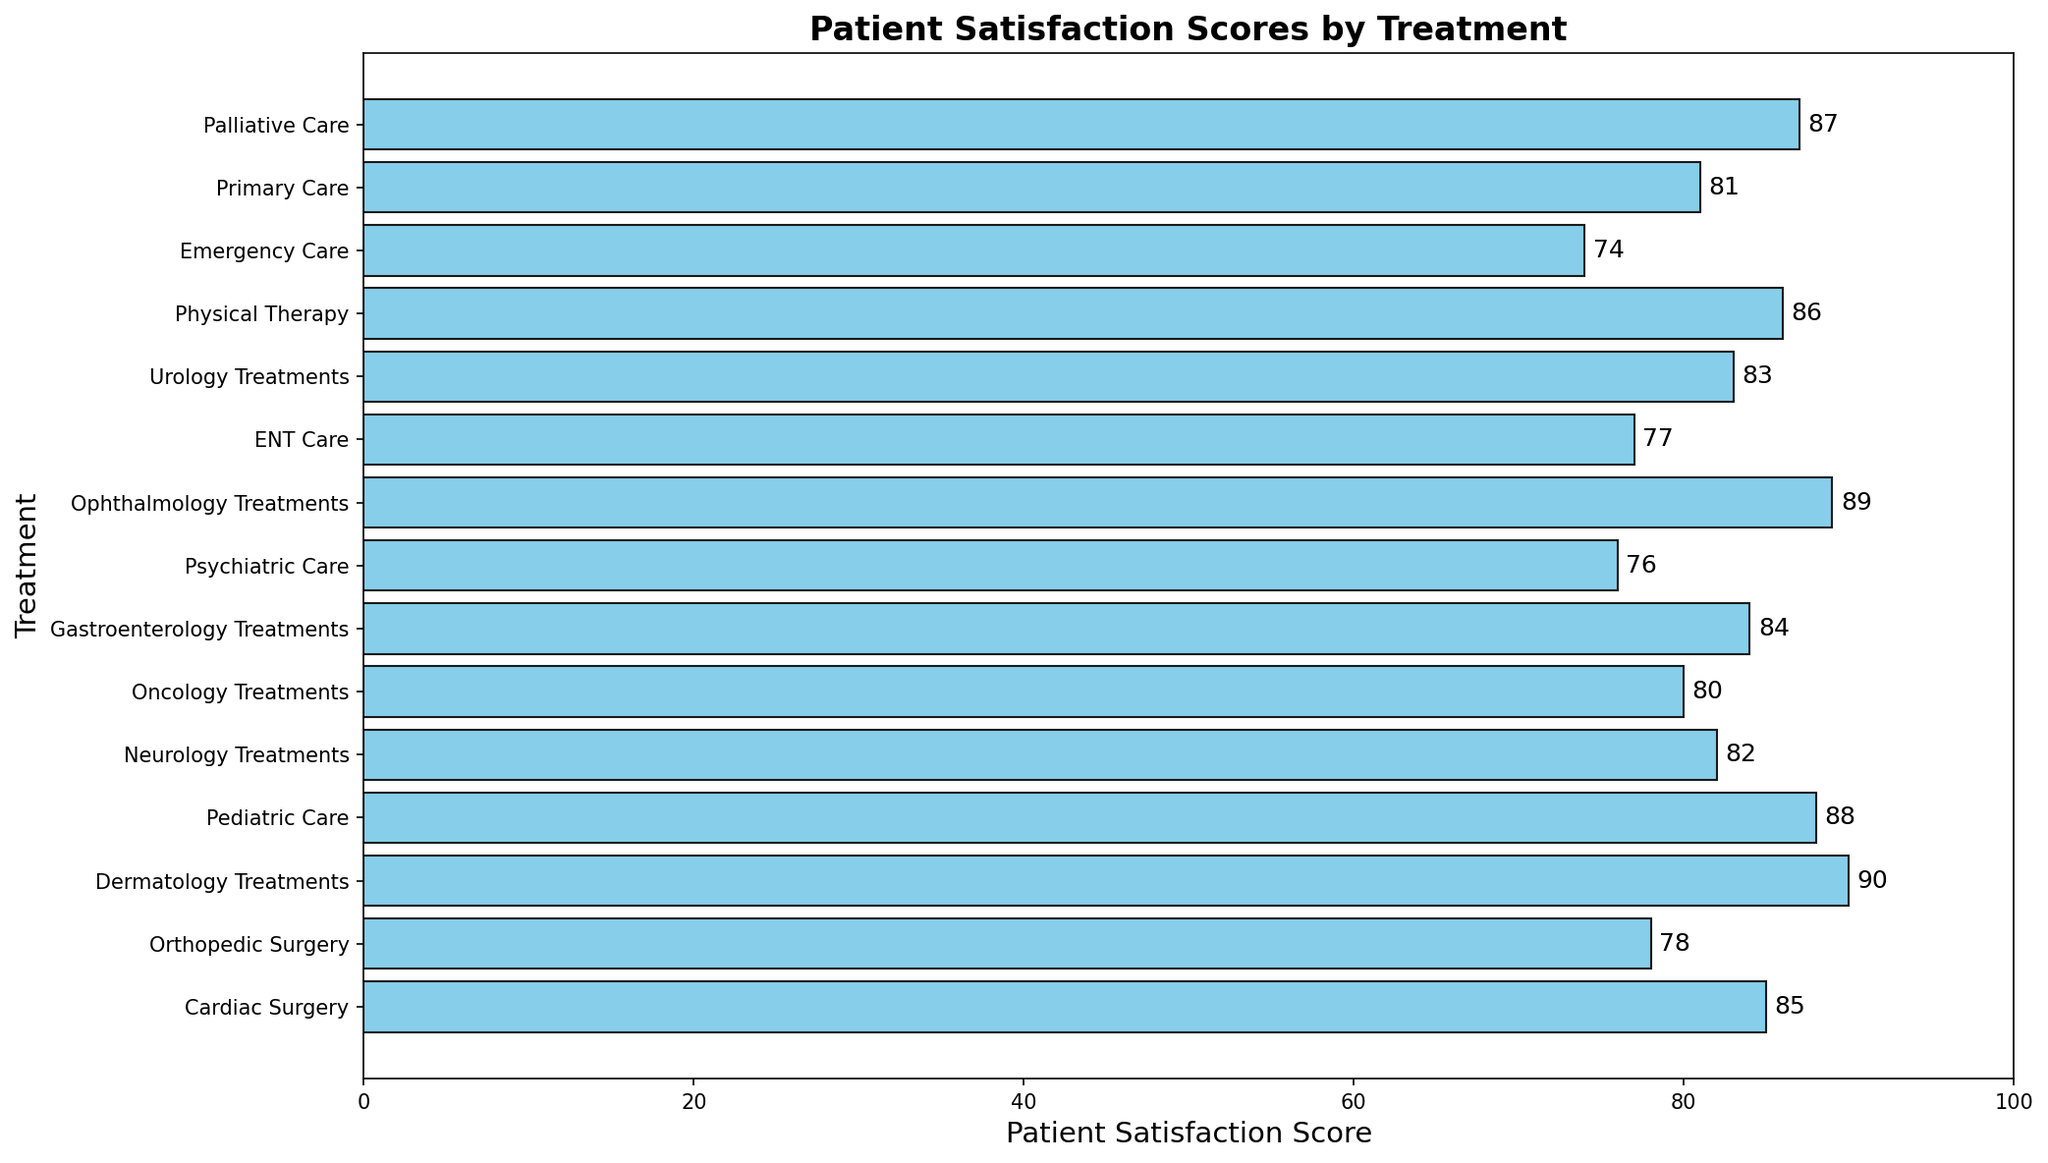What's the highest patient satisfaction score among all treatments? Look at the bar representing the highest score among all the treatments. Dermatology Treatments has the highest bar with a score of 90.
Answer: 90 Which treatment has the lowest patient satisfaction score? Identify the bar with the shortest length. Emergency Care has the shortest bar with a score of 74.
Answer: Emergency Care What is the difference in patient satisfaction scores between Dermatology Treatments and Psychiatric Care? Dermatology Treatments has a score of 90 and Psychiatric Care has a score of 76. The difference is 90 - 76 = 14.
Answer: 14 How many treatments have patient satisfaction scores higher than 80? Count the number of bars with scores greater than 80. There are 9 treatments with scores higher than 80.
Answer: 9 What is the average patient satisfaction score for Dermatology Treatments, Pediatric Care, and Palliative Care? Sum the scores of Dermatology Treatments (90), Pediatric Care (88), and Palliative Care (87) and divide by 3. (90 + 88 + 87) / 3 = 265 / 3 ≈ 88.33.
Answer: 88.33 Which treatment has closer patient satisfaction score to Neurology Treatments: Primary Care or Orthopedic Surgery? Neurology Treatments has a score of 82. Primary Care has a score of 81, and Orthopedic Surgery has a score of 78. The difference is 82 - 81 = 1 for Primary Care and 82 - 78 = 4 for Orthopedic Surgery. Primary Care has a closer score.
Answer: Primary Care Are there more treatments with satisfaction scores above or below 85? Count the treatments with scores above 85 and those below 85. There are 6 treatments above 85 and 9 treatments below 85. There are more treatments below 85.
Answer: Below 85 Which treatments have patient satisfaction scores between 80 and 85? Identify the bars with scores between 80 and 85. These treatments are Neurology Treatments (82), Oncology Treatments (80), Gastroenterology Treatments (84), Urology Treatments (83), and Primary Care (81).
Answer: Neurology Treatments, Oncology Treatments, Gastroenterology Treatments, Urology Treatments, Primary Care What is the total patient satisfaction score for Cardiac Surgery, Orthopedic Surgery, and Emergency Care? Sum the scores for Cardiac Surgery (85), Orthopedic Surgery (78), and Emergency Care (74). 85 + 78 + 74 = 237.
Answer: 237 Which two treatments have the closest patient satisfaction scores? Compare the difference between the scores of all treatments to find the smallest difference. Primary Care (81) and Neurology Treatments (82) have a difference of 1, which is the smallest.
Answer: Primary Care and Neurology Treatments 